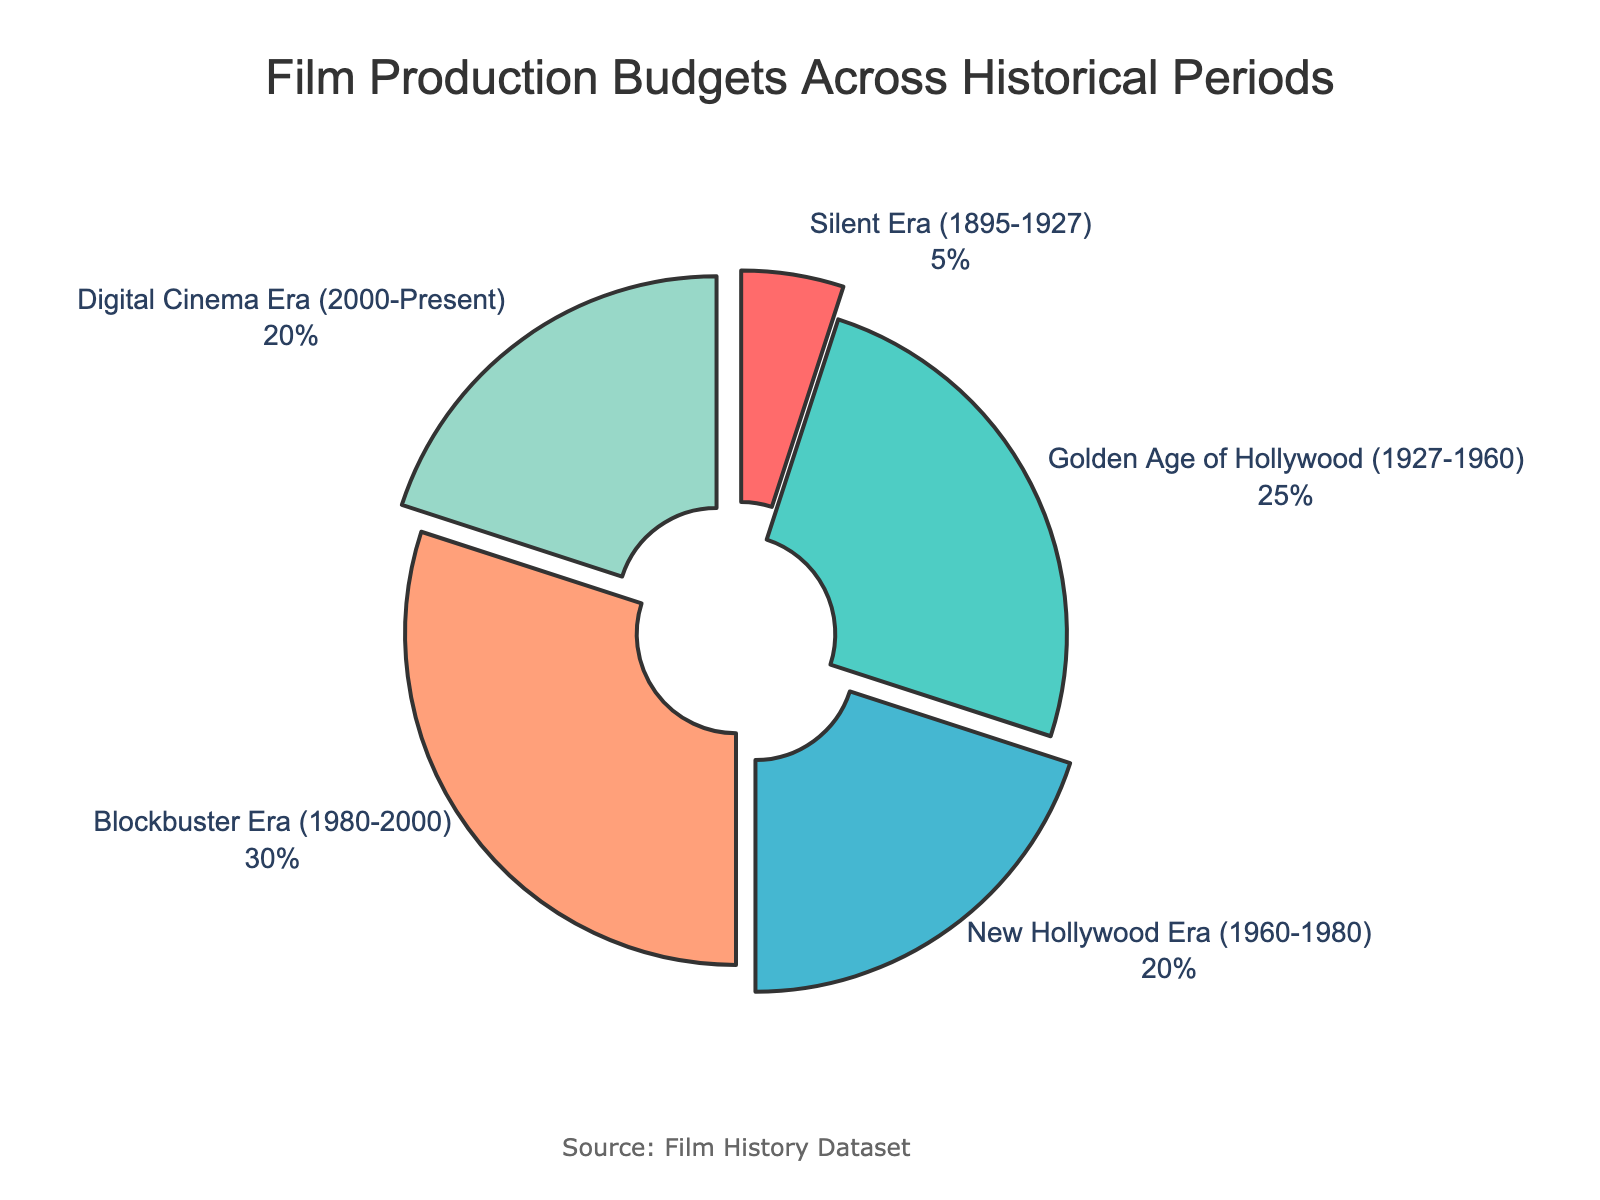What percentage of the total budget was allocated to the Silent Era (1895-1927)? The Silent Era received a specific slice of the pie chart indicating 5%.
Answer: 5% Which historical period had the highest proportion of film production budgets? The Blockbuster Era (1980-2000) has the largest slice of the pie chart, indicating it had the highest proportion.
Answer: Blockbuster Era (1980-2000) How much more budget proportion did the Blockbuster Era receive compared to the Silent Era? The Blockbuster Era received 30%, and the Silent Era received 5%. The difference is 30% - 5% = 25%.
Answer: 25% Which periods have an equal proportion of the film production budget? The New Hollywood Era (1960-1980) and the Digital Cinema Era (2000-Present) both have equal budget proportions of 20%.
Answer: New Hollywood Era and Digital Cinema Era What is the combined budget proportion of the Golden Age of Hollywood and the Digital Cinema Era? The Golden Age of Hollywood has 25%, and the Digital Cinema Era has 20%. The combined budget proportion is 25% + 20% = 45%.
Answer: 45% Which color represents the highest budget period in the pie chart? The Blockbuster Era (1980-2000) is represented by the largest slice in a certain color, which is visually identifiable in the chart.
Answer: Orange (Blockbuster Era color in the visual) Rank the historical periods from the highest to lowest proportion of film production budgets. The order from highest to lowest, according to the chart, is: Blockbuster Era, Golden Age of Hollywood, New Hollywood Era and Digital Cinema Era (tied), Silent Era.
Answer: Blockbuster Era > Golden Age of Hollywood > New Hollywood Era = Digital Cinema Era > Silent Era What portion of the budget is allocated to periods after 1960? Adding the proportions for the New Hollywood Era, Blockbuster Era, and Digital Cinema Era: 20% + 30% + 20% = 70%.
Answer: 70% If you were to combine the budgets of the Silent Era and the Golden Age of Hollywood, what proportion would you get? Sum the proportions: Silent Era (5%) + Golden Age of Hollywood (25%) = 30%.
Answer: 30% Which era is depicted with blue color in the pie chart and what is its budget proportion? The era depicted with blue color is indicated in the chart as the Digital Cinema Era (2000-Present), with a budget proportion of 20%.
Answer: Digital Cinema Era, 20% 